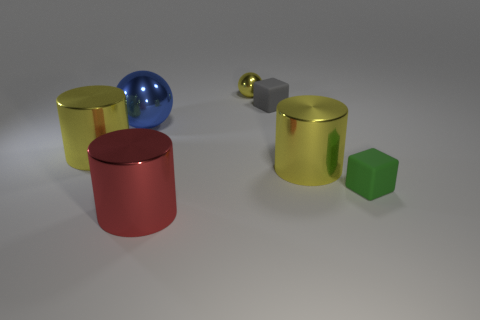Add 2 red metallic things. How many objects exist? 9 Subtract all yellow shiny cylinders. How many cylinders are left? 1 Subtract all green blocks. How many blocks are left? 1 Subtract all balls. How many objects are left? 5 Subtract all gray balls. How many red cylinders are left? 1 Subtract all blue balls. Subtract all big cyan spheres. How many objects are left? 6 Add 1 blue things. How many blue things are left? 2 Add 6 tiny metal objects. How many tiny metal objects exist? 7 Subtract 0 brown cylinders. How many objects are left? 7 Subtract 1 blocks. How many blocks are left? 1 